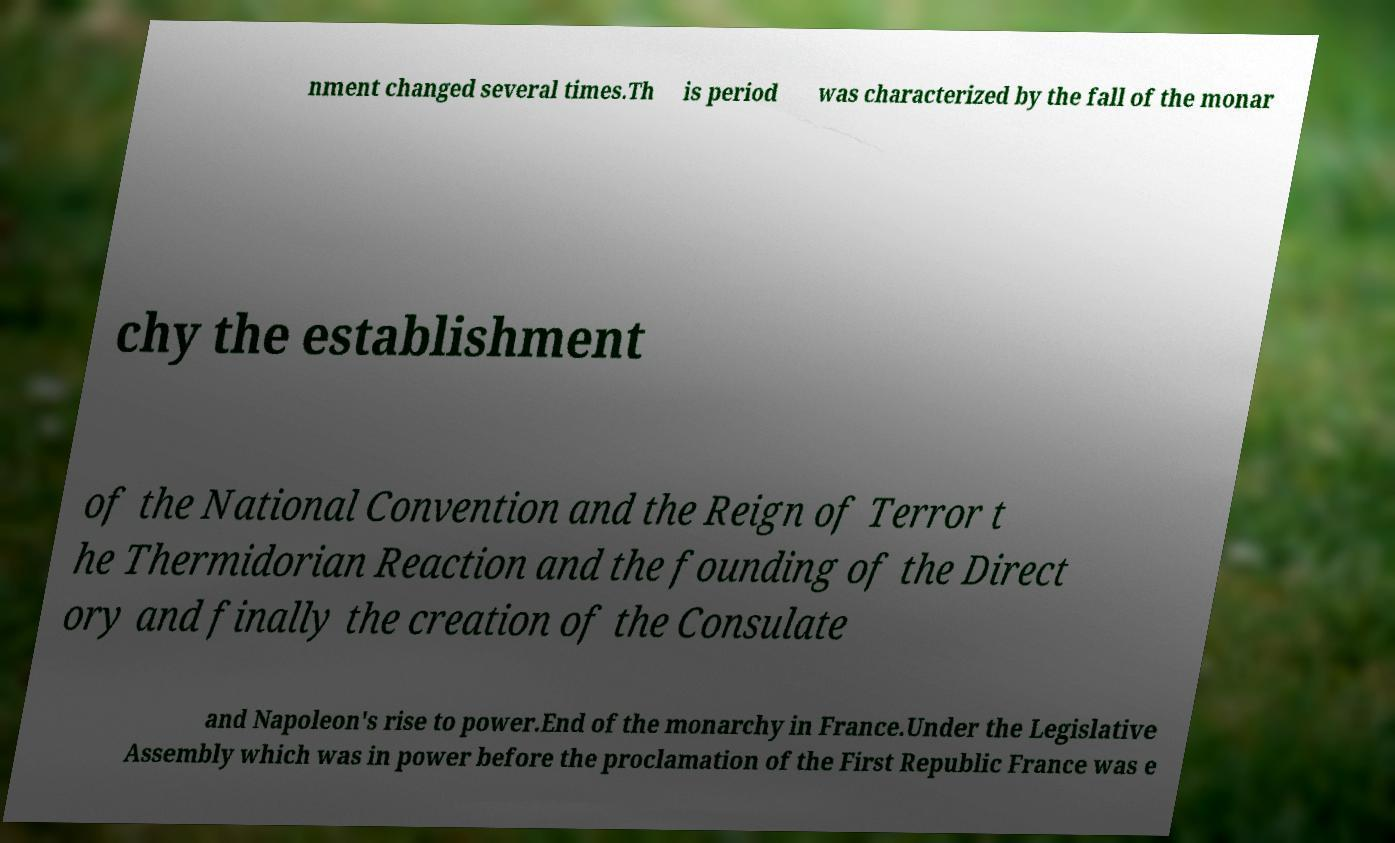Please read and relay the text visible in this image. What does it say? nment changed several times.Th is period was characterized by the fall of the monar chy the establishment of the National Convention and the Reign of Terror t he Thermidorian Reaction and the founding of the Direct ory and finally the creation of the Consulate and Napoleon's rise to power.End of the monarchy in France.Under the Legislative Assembly which was in power before the proclamation of the First Republic France was e 